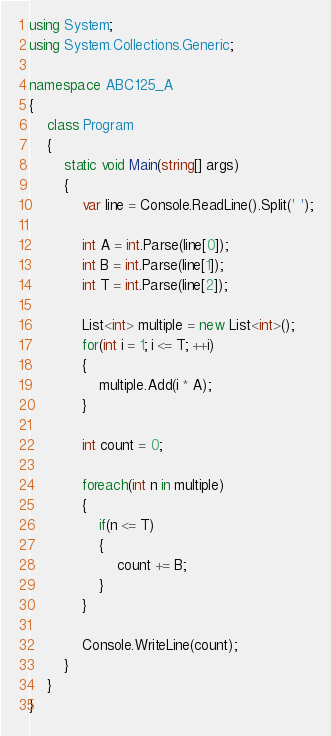Convert code to text. <code><loc_0><loc_0><loc_500><loc_500><_C#_>using System;
using System.Collections.Generic;

namespace ABC125_A
{
    class Program
    {
        static void Main(string[] args)
        {
            var line = Console.ReadLine().Split(' ');

            int A = int.Parse(line[0]);
            int B = int.Parse(line[1]);
            int T = int.Parse(line[2]);

            List<int> multiple = new List<int>();
            for(int i = 1; i <= T; ++i)
            {
                multiple.Add(i * A);
            }

            int count = 0;

            foreach(int n in multiple)
            {
                if(n <= T)
                {
                    count += B;
                }
            }

            Console.WriteLine(count);
        }
    }
}
</code> 